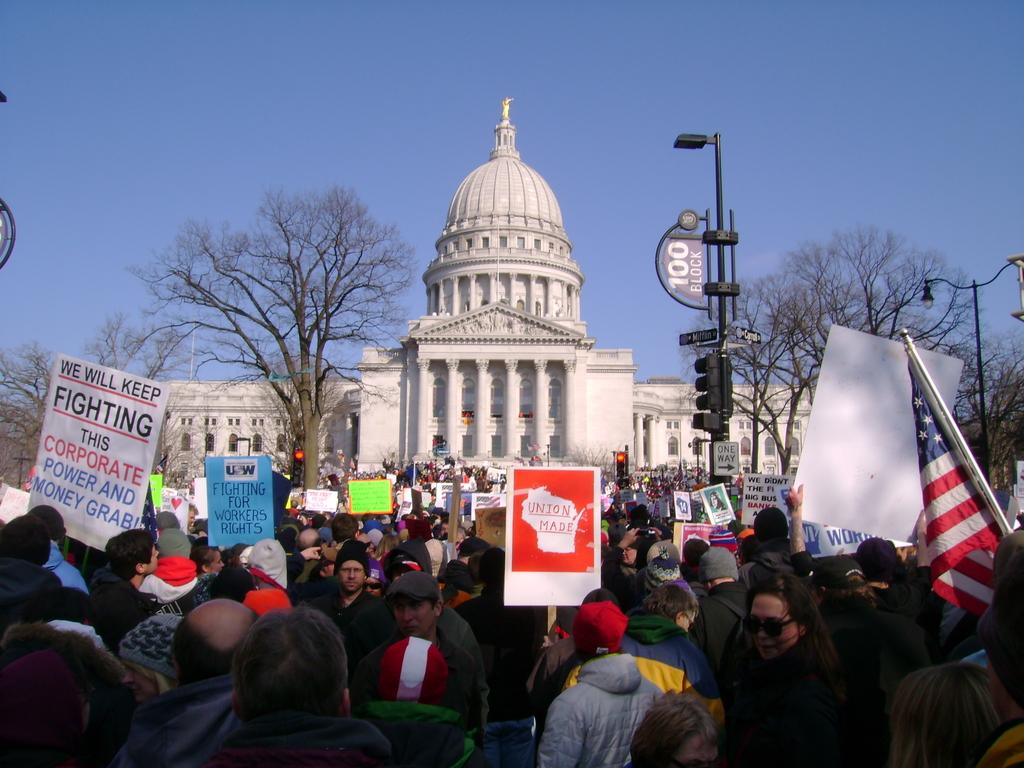How many people are in the image? There is a group of people in the image. What are the people holding in the image? The people are standing and holding boards and a flag. What can be seen in the background of the image? There are trees, lights, signal lights attached to poles, a building, and the sky visible in the background of the image. How many children are skateboarding in the image? There are no children or skateboards present in the image. 